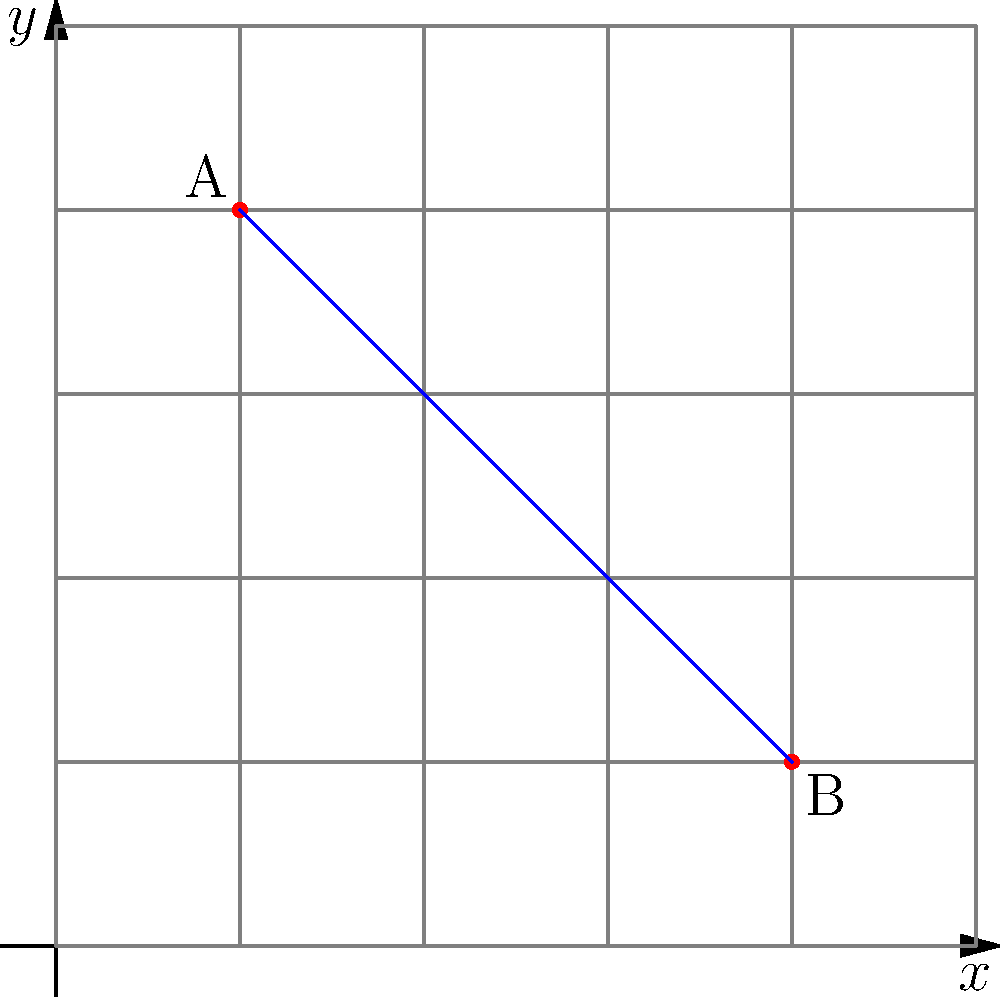During the Eastern Wei era, military strategists used a grid system to map outpost locations. Two key outposts, A and B, are located at coordinates (2,8) and (8,2) respectively. What is the straight-line distance between these two outposts? To find the straight-line distance between two points in a coordinate system, we can use the distance formula, which is derived from the Pythagorean theorem:

$$ d = \sqrt{(x_2-x_1)^2 + (y_2-y_1)^2} $$

Where $(x_1,y_1)$ are the coordinates of the first point and $(x_2,y_2)$ are the coordinates of the second point.

Given:
- Point A: $(2,8)$
- Point B: $(8,2)$

Let's plug these into the formula:

$$ d = \sqrt{(8-2)^2 + (2-8)^2} $$

Simplify inside the parentheses:
$$ d = \sqrt{6^2 + (-6)^2} $$

Calculate the squares:
$$ d = \sqrt{36 + 36} $$

Add inside the square root:
$$ d = \sqrt{72} $$

Simplify the square root:
$$ d = 6\sqrt{2} $$

This distance is measured in the same units as the grid system. In the context of Eastern Wei military strategy, this could represent a certain number of li (里), the traditional Chinese unit of distance.
Answer: $6\sqrt{2}$ units 